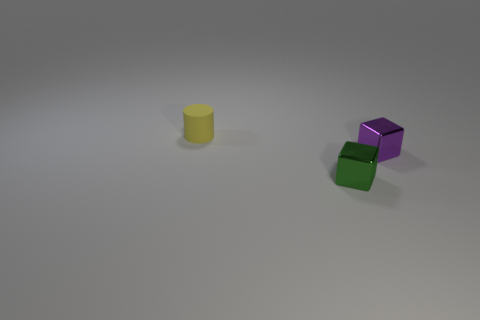What number of other things are there of the same material as the tiny yellow object
Keep it short and to the point. 0. What material is the tiny object on the left side of the tiny cube in front of the metallic block behind the small green object?
Give a very brief answer. Rubber. Is the material of the purple block the same as the green block?
Your answer should be compact. Yes. How many spheres are either metallic objects or purple metallic objects?
Provide a short and direct response. 0. There is a tiny shiny thing that is left of the purple object; what color is it?
Your answer should be compact. Green. What number of metallic objects are tiny green cubes or small cyan cubes?
Give a very brief answer. 1. What material is the tiny thing on the right side of the block that is in front of the small purple shiny block?
Offer a very short reply. Metal. What is the color of the tiny cylinder?
Provide a short and direct response. Yellow. There is a tiny shiny cube that is to the right of the green metallic cube; are there any blocks that are in front of it?
Provide a short and direct response. Yes. What is the material of the small purple thing?
Your answer should be very brief. Metal. 